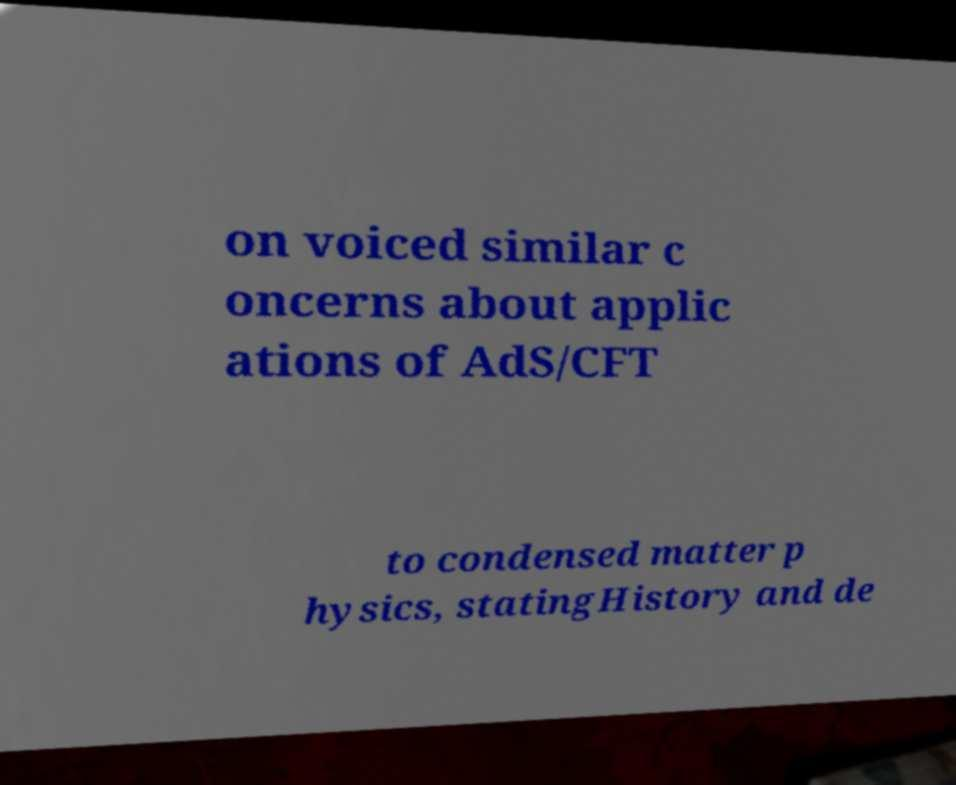Could you assist in decoding the text presented in this image and type it out clearly? on voiced similar c oncerns about applic ations of AdS/CFT to condensed matter p hysics, statingHistory and de 